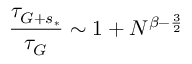Convert formula to latex. <formula><loc_0><loc_0><loc_500><loc_500>\frac { \tau _ { G + s _ { * } } } { \tau _ { G } } \sim 1 + N ^ { \beta - \frac { 3 } { 2 } }</formula> 